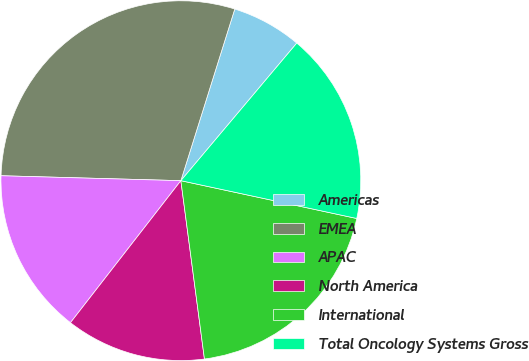Convert chart to OTSL. <chart><loc_0><loc_0><loc_500><loc_500><pie_chart><fcel>Americas<fcel>EMEA<fcel>APAC<fcel>North America<fcel>International<fcel>Total Oncology Systems Gross<nl><fcel>6.3%<fcel>29.41%<fcel>14.92%<fcel>12.61%<fcel>19.54%<fcel>17.23%<nl></chart> 